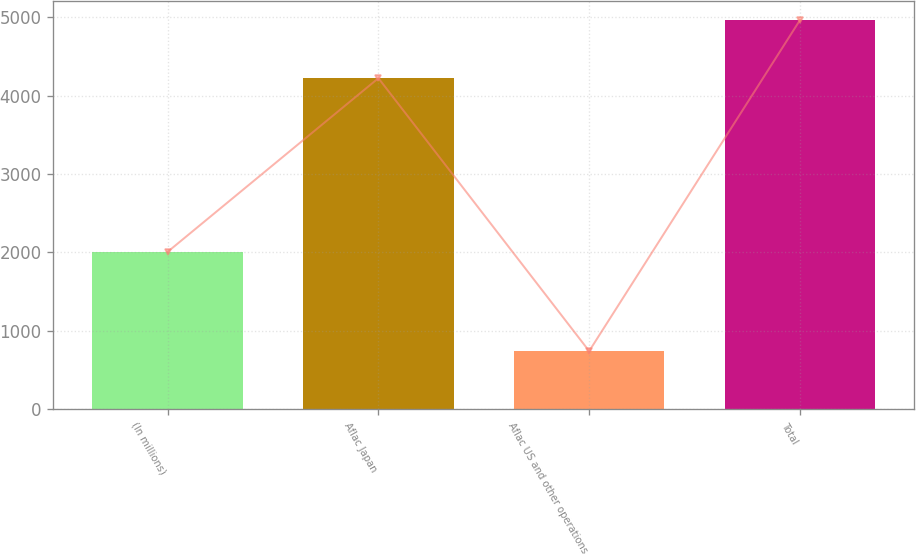<chart> <loc_0><loc_0><loc_500><loc_500><bar_chart><fcel>(In millions)<fcel>Aflac Japan<fcel>Aflac US and other operations<fcel>Total<nl><fcel>2008<fcel>4225<fcel>740<fcel>4965<nl></chart> 